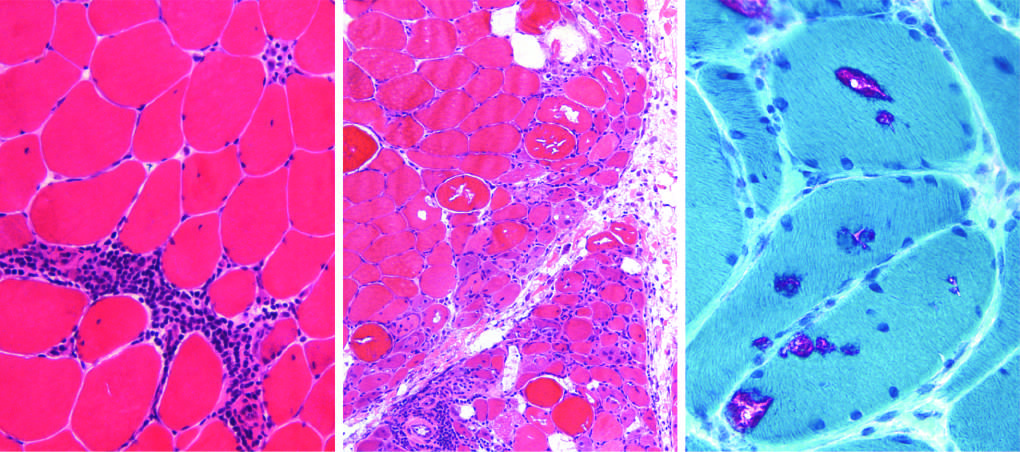what is characterized by endomysial inflammatory infiltrates and myofiber necrosis (arrow)?
Answer the question using a single word or phrase. Polymyositis 